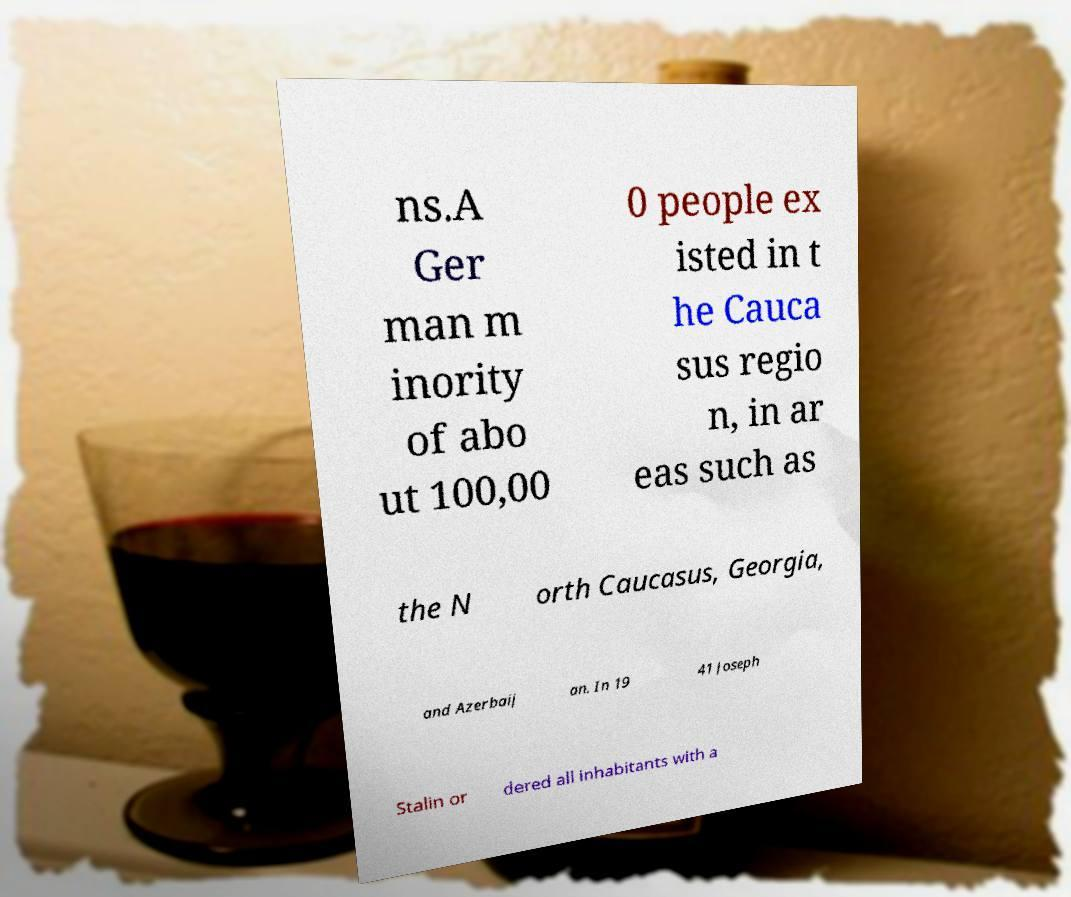Please identify and transcribe the text found in this image. ns.A Ger man m inority of abo ut 100,00 0 people ex isted in t he Cauca sus regio n, in ar eas such as the N orth Caucasus, Georgia, and Azerbaij an. In 19 41 Joseph Stalin or dered all inhabitants with a 